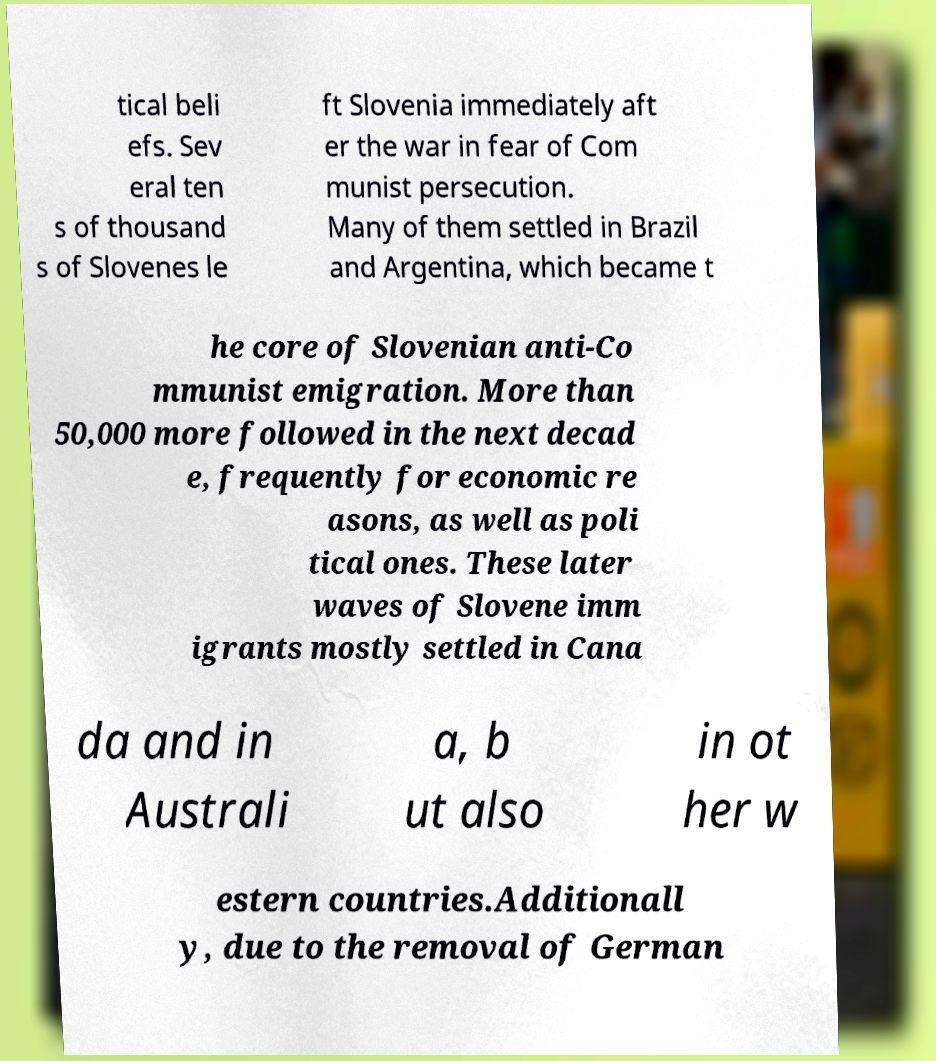Please identify and transcribe the text found in this image. tical beli efs. Sev eral ten s of thousand s of Slovenes le ft Slovenia immediately aft er the war in fear of Com munist persecution. Many of them settled in Brazil and Argentina, which became t he core of Slovenian anti-Co mmunist emigration. More than 50,000 more followed in the next decad e, frequently for economic re asons, as well as poli tical ones. These later waves of Slovene imm igrants mostly settled in Cana da and in Australi a, b ut also in ot her w estern countries.Additionall y, due to the removal of German 